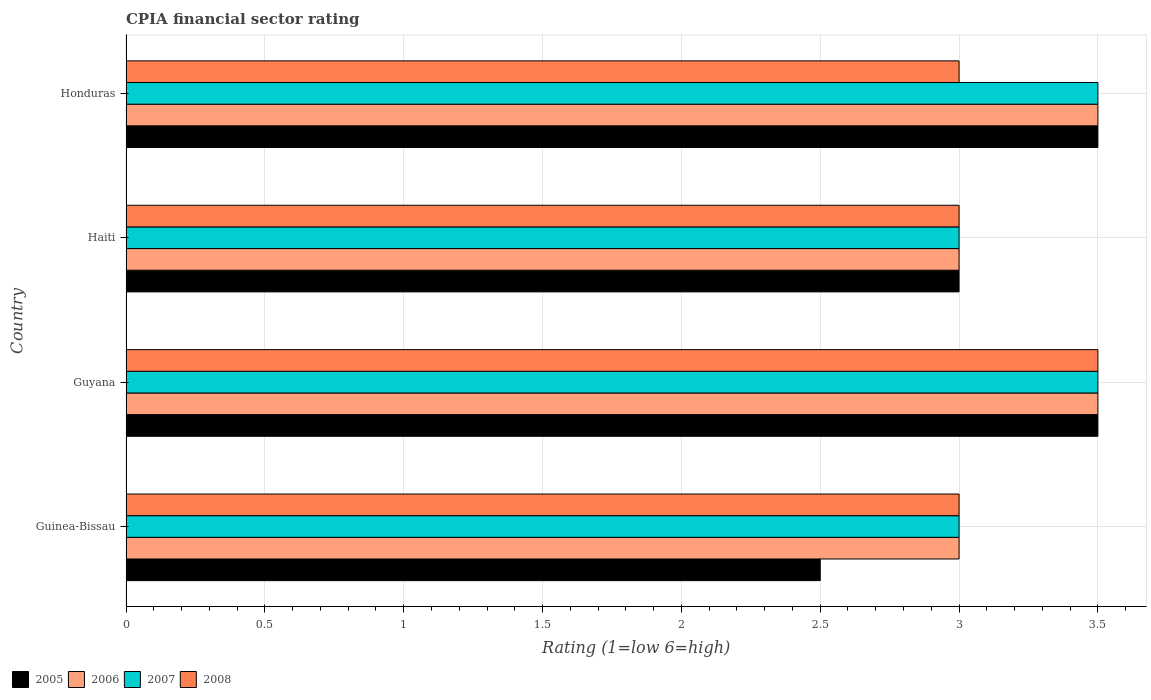How many groups of bars are there?
Provide a succinct answer. 4. How many bars are there on the 1st tick from the bottom?
Your answer should be compact. 4. What is the label of the 4th group of bars from the top?
Your response must be concise. Guinea-Bissau. In which country was the CPIA rating in 2008 maximum?
Keep it short and to the point. Guyana. In which country was the CPIA rating in 2006 minimum?
Your answer should be very brief. Guinea-Bissau. What is the ratio of the CPIA rating in 2006 in Guyana to that in Haiti?
Provide a short and direct response. 1.17. Is the difference between the CPIA rating in 2007 in Guinea-Bissau and Guyana greater than the difference between the CPIA rating in 2006 in Guinea-Bissau and Guyana?
Keep it short and to the point. No. What is the difference between the highest and the second highest CPIA rating in 2006?
Keep it short and to the point. 0. Is the sum of the CPIA rating in 2007 in Guyana and Honduras greater than the maximum CPIA rating in 2006 across all countries?
Your answer should be very brief. Yes. What does the 4th bar from the top in Guyana represents?
Provide a succinct answer. 2005. Is it the case that in every country, the sum of the CPIA rating in 2005 and CPIA rating in 2007 is greater than the CPIA rating in 2006?
Make the answer very short. Yes. How many bars are there?
Keep it short and to the point. 16. How many countries are there in the graph?
Provide a succinct answer. 4. What is the difference between two consecutive major ticks on the X-axis?
Ensure brevity in your answer.  0.5. Does the graph contain any zero values?
Keep it short and to the point. No. Where does the legend appear in the graph?
Offer a terse response. Bottom left. How many legend labels are there?
Keep it short and to the point. 4. How are the legend labels stacked?
Provide a short and direct response. Horizontal. What is the title of the graph?
Your answer should be very brief. CPIA financial sector rating. What is the Rating (1=low 6=high) of 2007 in Guinea-Bissau?
Provide a short and direct response. 3. What is the Rating (1=low 6=high) of 2008 in Guinea-Bissau?
Offer a very short reply. 3. What is the Rating (1=low 6=high) in 2007 in Guyana?
Your response must be concise. 3.5. What is the Rating (1=low 6=high) of 2008 in Guyana?
Keep it short and to the point. 3.5. What is the Rating (1=low 6=high) of 2006 in Haiti?
Make the answer very short. 3. What is the Rating (1=low 6=high) in 2008 in Haiti?
Provide a short and direct response. 3. What is the Rating (1=low 6=high) in 2006 in Honduras?
Your answer should be very brief. 3.5. Across all countries, what is the maximum Rating (1=low 6=high) in 2005?
Keep it short and to the point. 3.5. Across all countries, what is the maximum Rating (1=low 6=high) of 2006?
Your answer should be very brief. 3.5. Across all countries, what is the maximum Rating (1=low 6=high) of 2007?
Your response must be concise. 3.5. Across all countries, what is the minimum Rating (1=low 6=high) of 2005?
Give a very brief answer. 2.5. Across all countries, what is the minimum Rating (1=low 6=high) of 2007?
Make the answer very short. 3. Across all countries, what is the minimum Rating (1=low 6=high) of 2008?
Make the answer very short. 3. What is the total Rating (1=low 6=high) in 2006 in the graph?
Your answer should be compact. 13. What is the difference between the Rating (1=low 6=high) in 2007 in Guinea-Bissau and that in Guyana?
Keep it short and to the point. -0.5. What is the difference between the Rating (1=low 6=high) of 2005 in Guinea-Bissau and that in Haiti?
Keep it short and to the point. -0.5. What is the difference between the Rating (1=low 6=high) in 2006 in Guinea-Bissau and that in Haiti?
Ensure brevity in your answer.  0. What is the difference between the Rating (1=low 6=high) of 2008 in Guinea-Bissau and that in Haiti?
Make the answer very short. 0. What is the difference between the Rating (1=low 6=high) in 2006 in Guinea-Bissau and that in Honduras?
Your response must be concise. -0.5. What is the difference between the Rating (1=low 6=high) in 2006 in Guyana and that in Haiti?
Ensure brevity in your answer.  0.5. What is the difference between the Rating (1=low 6=high) in 2007 in Guyana and that in Haiti?
Make the answer very short. 0.5. What is the difference between the Rating (1=low 6=high) in 2006 in Guyana and that in Honduras?
Your response must be concise. 0. What is the difference between the Rating (1=low 6=high) in 2007 in Guyana and that in Honduras?
Your response must be concise. 0. What is the difference between the Rating (1=low 6=high) in 2008 in Guyana and that in Honduras?
Keep it short and to the point. 0.5. What is the difference between the Rating (1=low 6=high) in 2005 in Guinea-Bissau and the Rating (1=low 6=high) in 2006 in Guyana?
Offer a terse response. -1. What is the difference between the Rating (1=low 6=high) in 2005 in Guinea-Bissau and the Rating (1=low 6=high) in 2007 in Guyana?
Make the answer very short. -1. What is the difference between the Rating (1=low 6=high) in 2005 in Guinea-Bissau and the Rating (1=low 6=high) in 2008 in Guyana?
Your response must be concise. -1. What is the difference between the Rating (1=low 6=high) of 2006 in Guinea-Bissau and the Rating (1=low 6=high) of 2007 in Guyana?
Offer a very short reply. -0.5. What is the difference between the Rating (1=low 6=high) in 2007 in Guinea-Bissau and the Rating (1=low 6=high) in 2008 in Guyana?
Ensure brevity in your answer.  -0.5. What is the difference between the Rating (1=low 6=high) of 2005 in Guinea-Bissau and the Rating (1=low 6=high) of 2006 in Haiti?
Your answer should be compact. -0.5. What is the difference between the Rating (1=low 6=high) of 2006 in Guinea-Bissau and the Rating (1=low 6=high) of 2007 in Haiti?
Your answer should be very brief. 0. What is the difference between the Rating (1=low 6=high) in 2005 in Guinea-Bissau and the Rating (1=low 6=high) in 2008 in Honduras?
Provide a short and direct response. -0.5. What is the difference between the Rating (1=low 6=high) in 2006 in Guinea-Bissau and the Rating (1=low 6=high) in 2007 in Honduras?
Make the answer very short. -0.5. What is the difference between the Rating (1=low 6=high) of 2006 in Guinea-Bissau and the Rating (1=low 6=high) of 2008 in Honduras?
Give a very brief answer. 0. What is the difference between the Rating (1=low 6=high) of 2005 in Guyana and the Rating (1=low 6=high) of 2008 in Haiti?
Keep it short and to the point. 0.5. What is the difference between the Rating (1=low 6=high) in 2007 in Guyana and the Rating (1=low 6=high) in 2008 in Haiti?
Provide a succinct answer. 0.5. What is the difference between the Rating (1=low 6=high) of 2005 in Guyana and the Rating (1=low 6=high) of 2006 in Honduras?
Provide a short and direct response. 0. What is the difference between the Rating (1=low 6=high) of 2005 in Guyana and the Rating (1=low 6=high) of 2007 in Honduras?
Provide a succinct answer. 0. What is the difference between the Rating (1=low 6=high) of 2006 in Guyana and the Rating (1=low 6=high) of 2007 in Honduras?
Provide a short and direct response. 0. What is the difference between the Rating (1=low 6=high) of 2006 in Guyana and the Rating (1=low 6=high) of 2008 in Honduras?
Provide a short and direct response. 0.5. What is the difference between the Rating (1=low 6=high) in 2005 in Haiti and the Rating (1=low 6=high) in 2007 in Honduras?
Your answer should be compact. -0.5. What is the difference between the Rating (1=low 6=high) in 2006 in Haiti and the Rating (1=low 6=high) in 2008 in Honduras?
Make the answer very short. 0. What is the difference between the Rating (1=low 6=high) of 2007 in Haiti and the Rating (1=low 6=high) of 2008 in Honduras?
Provide a short and direct response. 0. What is the average Rating (1=low 6=high) of 2005 per country?
Your answer should be compact. 3.12. What is the average Rating (1=low 6=high) of 2006 per country?
Provide a succinct answer. 3.25. What is the average Rating (1=low 6=high) of 2008 per country?
Give a very brief answer. 3.12. What is the difference between the Rating (1=low 6=high) in 2005 and Rating (1=low 6=high) in 2008 in Guinea-Bissau?
Make the answer very short. -0.5. What is the difference between the Rating (1=low 6=high) in 2006 and Rating (1=low 6=high) in 2008 in Guinea-Bissau?
Your response must be concise. 0. What is the difference between the Rating (1=low 6=high) in 2007 and Rating (1=low 6=high) in 2008 in Guinea-Bissau?
Offer a terse response. 0. What is the difference between the Rating (1=low 6=high) of 2005 and Rating (1=low 6=high) of 2007 in Guyana?
Provide a short and direct response. 0. What is the difference between the Rating (1=low 6=high) of 2005 and Rating (1=low 6=high) of 2008 in Guyana?
Keep it short and to the point. 0. What is the difference between the Rating (1=low 6=high) in 2006 and Rating (1=low 6=high) in 2008 in Guyana?
Provide a succinct answer. 0. What is the difference between the Rating (1=low 6=high) in 2005 and Rating (1=low 6=high) in 2006 in Haiti?
Offer a terse response. 0. What is the difference between the Rating (1=low 6=high) in 2005 and Rating (1=low 6=high) in 2007 in Haiti?
Provide a short and direct response. 0. What is the difference between the Rating (1=low 6=high) in 2006 and Rating (1=low 6=high) in 2007 in Haiti?
Your answer should be compact. 0. What is the difference between the Rating (1=low 6=high) in 2007 and Rating (1=low 6=high) in 2008 in Haiti?
Your answer should be compact. 0. What is the difference between the Rating (1=low 6=high) of 2005 and Rating (1=low 6=high) of 2006 in Honduras?
Your response must be concise. 0. What is the difference between the Rating (1=low 6=high) of 2005 and Rating (1=low 6=high) of 2008 in Honduras?
Your answer should be very brief. 0.5. What is the difference between the Rating (1=low 6=high) in 2006 and Rating (1=low 6=high) in 2007 in Honduras?
Ensure brevity in your answer.  0. What is the ratio of the Rating (1=low 6=high) in 2005 in Guinea-Bissau to that in Guyana?
Your answer should be compact. 0.71. What is the ratio of the Rating (1=low 6=high) of 2008 in Guinea-Bissau to that in Guyana?
Keep it short and to the point. 0.86. What is the ratio of the Rating (1=low 6=high) of 2005 in Guinea-Bissau to that in Haiti?
Give a very brief answer. 0.83. What is the ratio of the Rating (1=low 6=high) of 2008 in Guinea-Bissau to that in Haiti?
Provide a short and direct response. 1. What is the ratio of the Rating (1=low 6=high) in 2006 in Guinea-Bissau to that in Honduras?
Offer a very short reply. 0.86. What is the ratio of the Rating (1=low 6=high) in 2007 in Guinea-Bissau to that in Honduras?
Give a very brief answer. 0.86. What is the ratio of the Rating (1=low 6=high) of 2008 in Guinea-Bissau to that in Honduras?
Ensure brevity in your answer.  1. What is the ratio of the Rating (1=low 6=high) in 2005 in Guyana to that in Haiti?
Your answer should be compact. 1.17. What is the ratio of the Rating (1=low 6=high) in 2006 in Guyana to that in Haiti?
Provide a succinct answer. 1.17. What is the ratio of the Rating (1=low 6=high) of 2007 in Guyana to that in Haiti?
Give a very brief answer. 1.17. What is the ratio of the Rating (1=low 6=high) in 2008 in Guyana to that in Haiti?
Your answer should be compact. 1.17. What is the ratio of the Rating (1=low 6=high) in 2005 in Guyana to that in Honduras?
Give a very brief answer. 1. What is the ratio of the Rating (1=low 6=high) in 2006 in Guyana to that in Honduras?
Offer a very short reply. 1. What is the ratio of the Rating (1=low 6=high) of 2007 in Guyana to that in Honduras?
Ensure brevity in your answer.  1. What is the ratio of the Rating (1=low 6=high) of 2008 in Guyana to that in Honduras?
Make the answer very short. 1.17. What is the ratio of the Rating (1=low 6=high) in 2007 in Haiti to that in Honduras?
Your response must be concise. 0.86. What is the ratio of the Rating (1=low 6=high) in 2008 in Haiti to that in Honduras?
Provide a succinct answer. 1. What is the difference between the highest and the second highest Rating (1=low 6=high) in 2005?
Your response must be concise. 0. What is the difference between the highest and the second highest Rating (1=low 6=high) in 2007?
Offer a terse response. 0. What is the difference between the highest and the lowest Rating (1=low 6=high) in 2005?
Keep it short and to the point. 1. 